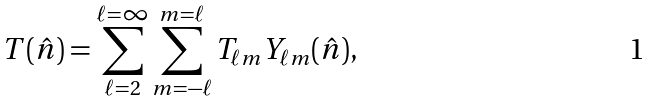<formula> <loc_0><loc_0><loc_500><loc_500>T ( \hat { n } ) = \sum _ { \ell = 2 } ^ { \ell = \infty } \sum _ { m = - \ell } ^ { m = \ell } T _ { \ell m } Y _ { \ell m } ( \hat { n } ) ,</formula> 